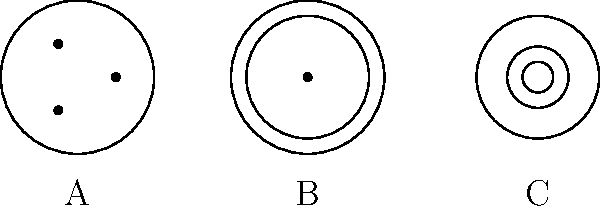As a music teacher focusing on technical skills for audio recording, identify the types of audio connectors represented by the cross-sectional diagrams labeled A, B, and C. To identify these audio connectors, let's analyze each diagram:

1. Diagram A:
   - Shows three dots in a triangular arrangement within a circle.
   - This is characteristic of an XLR (External Line Return) connector.
   - XLR connectors are commonly used for balanced audio signals in professional audio equipment.

2. Diagram B:
   - Depicts two concentric circles with a single dot in the center.
   - This represents an RCA (Radio Corporation of America) connector.
   - RCA connectors are often used for unbalanced audio signals in consumer audio equipment.

3. Diagram C:
   - Shows three concentric circles.
   - This is indicative of a TRS (Tip-Ring-Sleeve) connector.
   - TRS connectors can be used for balanced mono signals or unbalanced stereo signals.

Understanding these connectors is crucial for proper audio setup and signal flow in recording situations.
Answer: A: XLR, B: RCA, C: TRS 